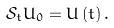<formula> <loc_0><loc_0><loc_500><loc_500>\mathcal { S } _ { t } U _ { 0 } = U \left ( t \right ) .</formula> 